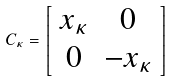Convert formula to latex. <formula><loc_0><loc_0><loc_500><loc_500>C _ { \kappa } = \left [ \begin{array} { c c } x _ { \kappa } & 0 \\ 0 & - x _ { \kappa } \end{array} \right ]</formula> 